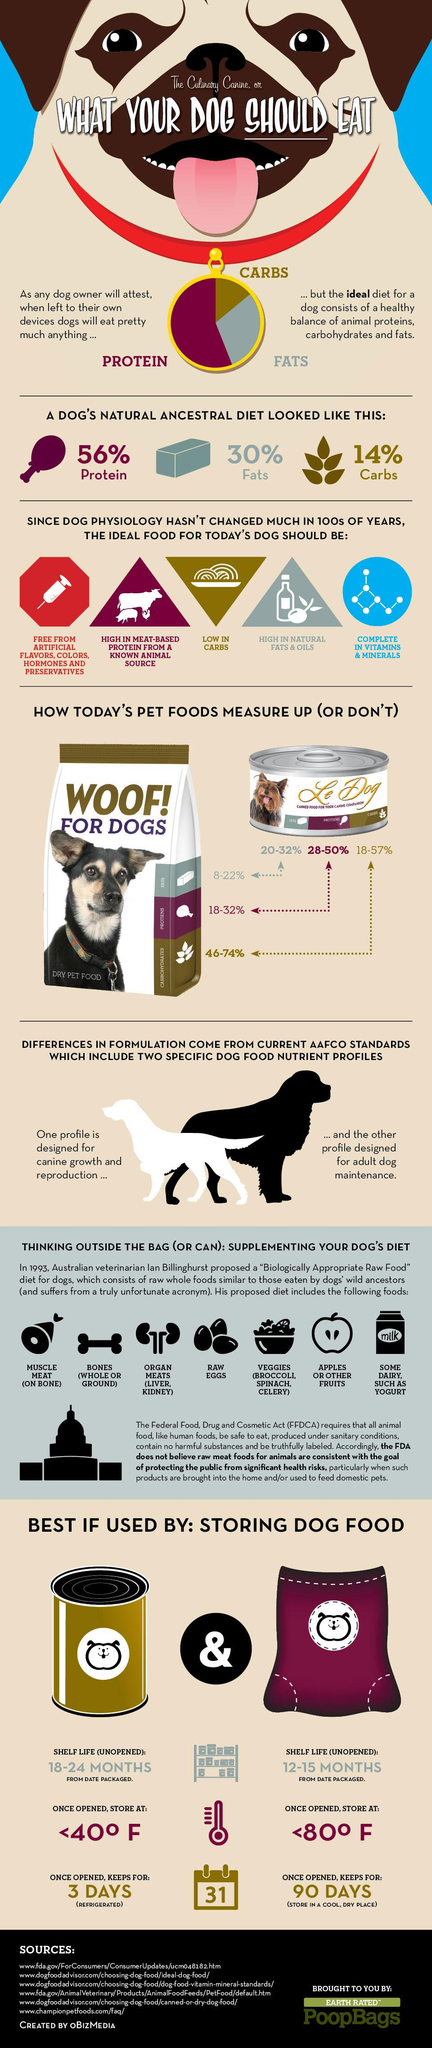Identify some key points in this picture. Five features of the ideal food for today's dogs are mentioned. Canned dog food typically has a longer shelf life than dry dog food, making it a more convenient option for pet owners. The shelf life for canned dog food is 18 to 24 months from the date of packaging, during which time it can be safely stored and consumed. Once opened, canned dog food can be stored for a longer period of time compared to dry dog food. In fact, canned dog food is a superior choice for pet owners who want to ensure their furry friends receive the nutrition they need, without wasting any food. The third feature mentioned under 'the ideal food for today's dog' is a low carbohydrate content, which is crucial for maintaining optimal health and wellness in our furry companions. 